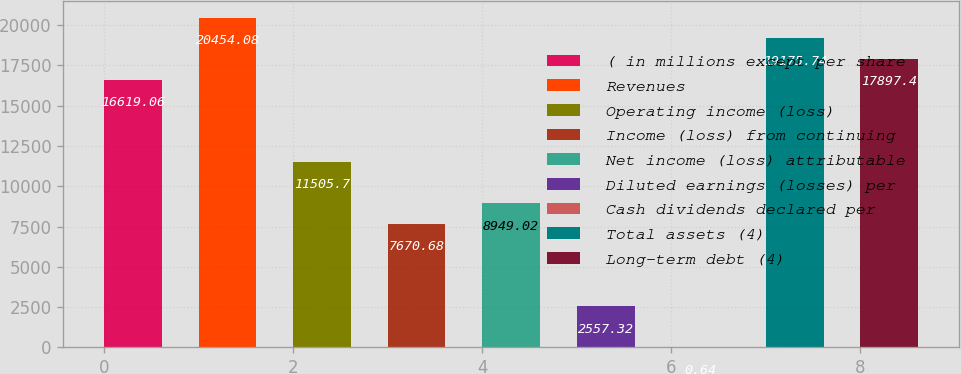<chart> <loc_0><loc_0><loc_500><loc_500><bar_chart><fcel>( in millions except per share<fcel>Revenues<fcel>Operating income (loss)<fcel>Income (loss) from continuing<fcel>Net income (loss) attributable<fcel>Diluted earnings (losses) per<fcel>Cash dividends declared per<fcel>Total assets (4)<fcel>Long-term debt (4)<nl><fcel>16619.1<fcel>20454.1<fcel>11505.7<fcel>7670.68<fcel>8949.02<fcel>2557.32<fcel>0.64<fcel>19175.7<fcel>17897.4<nl></chart> 